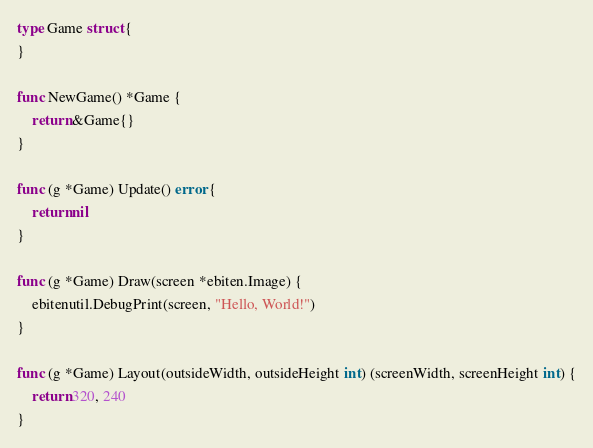Convert code to text. <code><loc_0><loc_0><loc_500><loc_500><_Go_>type Game struct {
}

func NewGame() *Game {
	return &Game{}
}

func (g *Game) Update() error {
	return nil
}

func (g *Game) Draw(screen *ebiten.Image) {
	ebitenutil.DebugPrint(screen, "Hello, World!")
}

func (g *Game) Layout(outsideWidth, outsideHeight int) (screenWidth, screenHeight int) {
	return 320, 240
}
</code> 